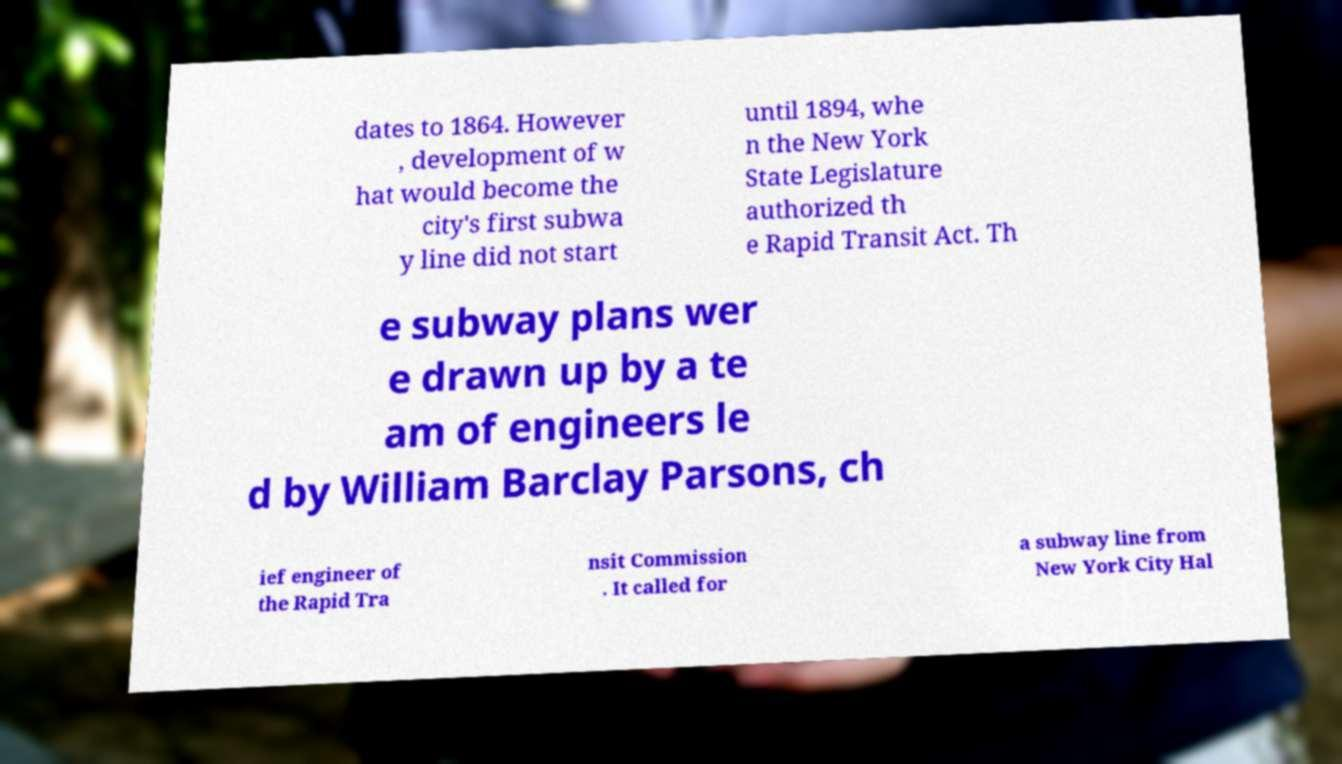Please read and relay the text visible in this image. What does it say? dates to 1864. However , development of w hat would become the city's first subwa y line did not start until 1894, whe n the New York State Legislature authorized th e Rapid Transit Act. Th e subway plans wer e drawn up by a te am of engineers le d by William Barclay Parsons, ch ief engineer of the Rapid Tra nsit Commission . It called for a subway line from New York City Hal 